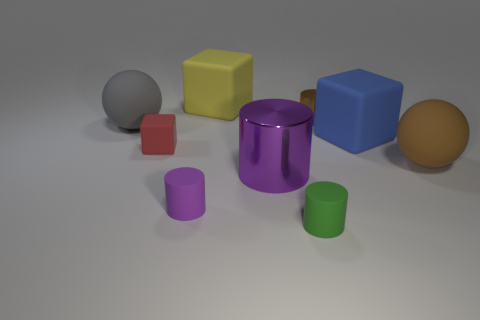There is a big brown sphere; how many brown spheres are behind it?
Offer a very short reply. 0. Is the color of the big cylinder that is behind the green cylinder the same as the tiny shiny cylinder?
Ensure brevity in your answer.  No. What number of blue matte cylinders are the same size as the gray rubber sphere?
Make the answer very short. 0. There is a red thing that is made of the same material as the small purple cylinder; what shape is it?
Ensure brevity in your answer.  Cube. Are there any large matte things of the same color as the tiny block?
Offer a very short reply. No. What is the material of the big cylinder?
Offer a very short reply. Metal. What number of things are either large red cylinders or tiny purple cylinders?
Your answer should be very brief. 1. How big is the matte sphere that is behind the red block?
Make the answer very short. Large. How many other objects are the same material as the tiny green cylinder?
Ensure brevity in your answer.  6. Is there a big gray object that is behind the cylinder on the left side of the big yellow rubber block?
Keep it short and to the point. Yes. 